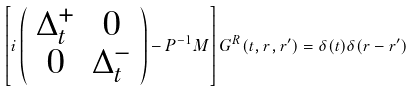Convert formula to latex. <formula><loc_0><loc_0><loc_500><loc_500>\left [ i \left ( \begin{array} { c c } \Delta ^ { + } _ { t } & 0 \\ 0 & \Delta ^ { - } _ { t } \end{array} \right ) - { P } ^ { - 1 } { M } \right ] { G } ^ { R } ( t , { r } , { r ^ { \prime } } ) = \delta ( t ) \delta ( { r - r ^ { \prime } } )</formula> 